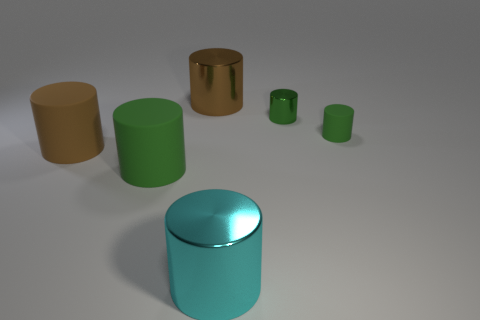Do the green rubber thing in front of the small green matte thing and the matte object that is to the right of the big brown metal cylinder have the same size?
Give a very brief answer. No. Are the cyan object and the green object that is to the left of the big cyan metal cylinder made of the same material?
Your answer should be very brief. No. Is the number of small green objects that are to the right of the big cyan cylinder greater than the number of matte things that are in front of the large green object?
Your answer should be compact. Yes. There is a large shiny cylinder that is behind the tiny green metal thing behind the brown matte cylinder; what color is it?
Your answer should be compact. Brown. What number of cubes are tiny purple objects or big brown shiny things?
Ensure brevity in your answer.  0. How many cylinders are in front of the large brown matte cylinder and right of the brown shiny cylinder?
Ensure brevity in your answer.  1. What is the color of the big rubber thing in front of the big brown rubber cylinder?
Make the answer very short. Green. There is a brown cylinder that is made of the same material as the large cyan cylinder; what size is it?
Make the answer very short. Large. There is a matte cylinder that is to the right of the cyan metallic cylinder; what number of green shiny things are on the right side of it?
Offer a very short reply. 0. What number of cylinders are behind the small green rubber thing?
Your response must be concise. 2. 